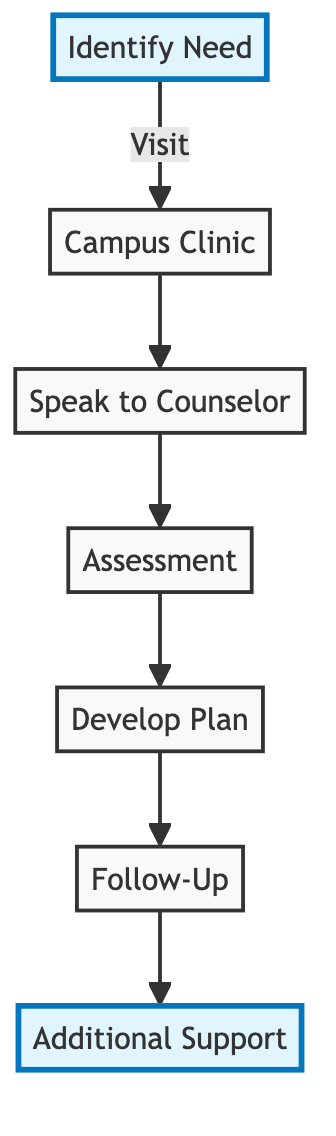What is the first step in the pathway? The diagram indicates that the first step is "Identify Need." This is listed as the starting point from which all subsequent steps follow.
Answer: Identify Need How many total steps are there to access mental health support? By counting the nodes in the diagram, there are a total of 7 steps clearly depicted in the pathway.
Answer: 7 Which step comes after "Assessment"? The diagram shows that the step following "Assessment" is "Develop Plan," indicating the progression from assessment to planning treatment.
Answer: Develop Plan What is the last step in the pathway? According to the diagram, the last step listed is "Additional Support," which indicates the final stage in the process of accessing mental health services.
Answer: Additional Support Which step involves speaking to a mental health professional? The step "Speak to Counselor" specifically mentions having a conversation with a mental health counselor, highlighting the focus on communication with a professional.
Answer: Speak to Counselor What two steps are highlighted in the diagram? The highlighted steps in the diagram are "Identify Need" and "Additional Support," indicating they might be of particular emphasis in the pathway.
Answer: Identify Need, Additional Support What step involves tracking progress? The step where tracking progress is emphasized is "Follow-Up," indicating the ongoing assessment of the treatment plan's effectiveness.
Answer: Follow-Up What needs to happen before developing a treatment plan? Before developing a treatment plan, the diagram indicates that there must be an "Assessment," which involves evaluating the individual's needs first.
Answer: Assessment How do you access mental health support services? To access mental health support services, follow the steps starting from identifying the need, visiting the campus clinic, and then proceeding through the outlined steps in the diagram.
Answer: Follow the steps in the pathway 